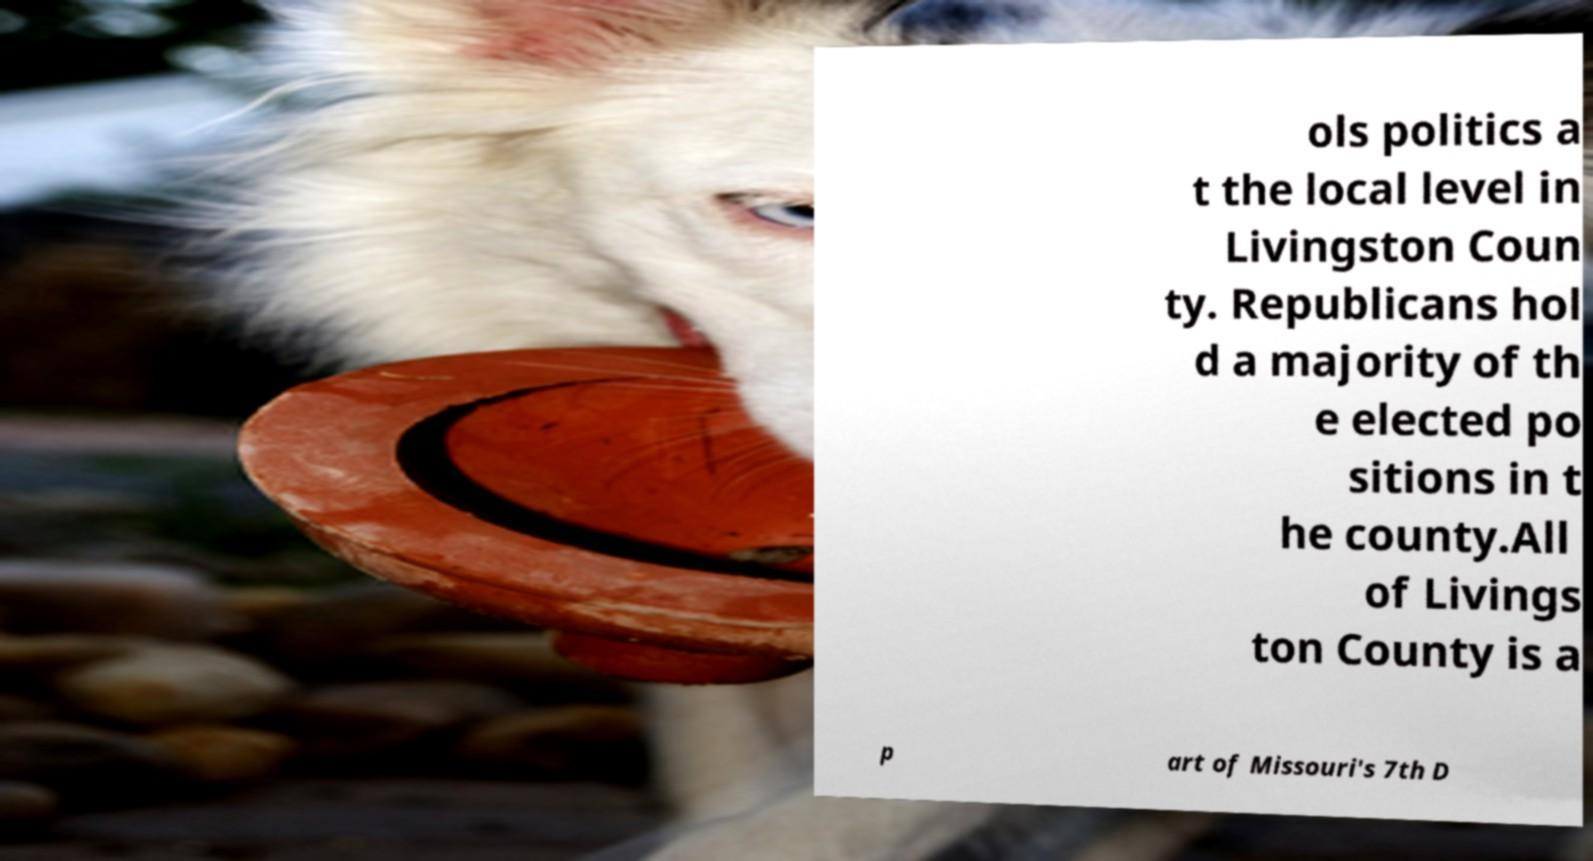For documentation purposes, I need the text within this image transcribed. Could you provide that? ols politics a t the local level in Livingston Coun ty. Republicans hol d a majority of th e elected po sitions in t he county.All of Livings ton County is a p art of Missouri's 7th D 